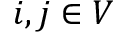Convert formula to latex. <formula><loc_0><loc_0><loc_500><loc_500>i , j \in V</formula> 